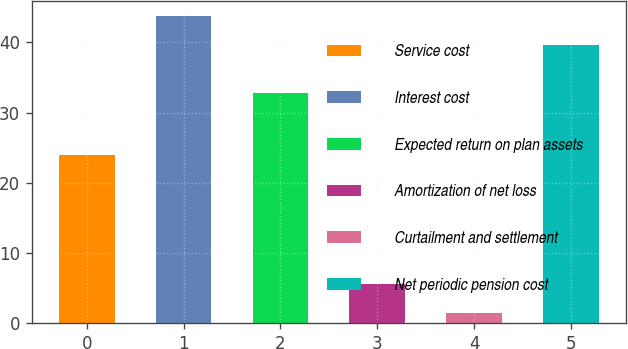<chart> <loc_0><loc_0><loc_500><loc_500><bar_chart><fcel>Service cost<fcel>Interest cost<fcel>Expected return on plan assets<fcel>Amortization of net loss<fcel>Curtailment and settlement<fcel>Net periodic pension cost<nl><fcel>23.9<fcel>43.7<fcel>32.8<fcel>5.6<fcel>1.5<fcel>39.6<nl></chart> 